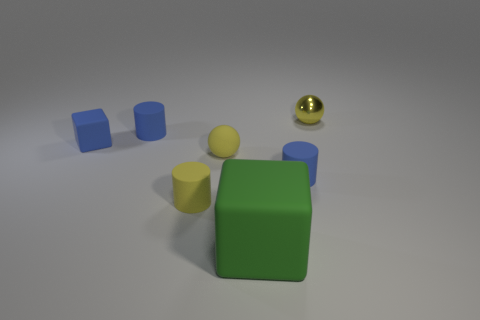Subtract all blue blocks. How many blue cylinders are left? 2 Add 2 brown metal cylinders. How many objects exist? 9 Subtract all yellow rubber cylinders. How many cylinders are left? 2 Subtract 1 cylinders. How many cylinders are left? 2 Subtract all cylinders. How many objects are left? 4 Subtract 0 gray spheres. How many objects are left? 7 Subtract all red balls. Subtract all blue cylinders. How many balls are left? 2 Subtract all large objects. Subtract all yellow rubber cylinders. How many objects are left? 5 Add 2 small blocks. How many small blocks are left? 3 Add 5 blue cylinders. How many blue cylinders exist? 7 